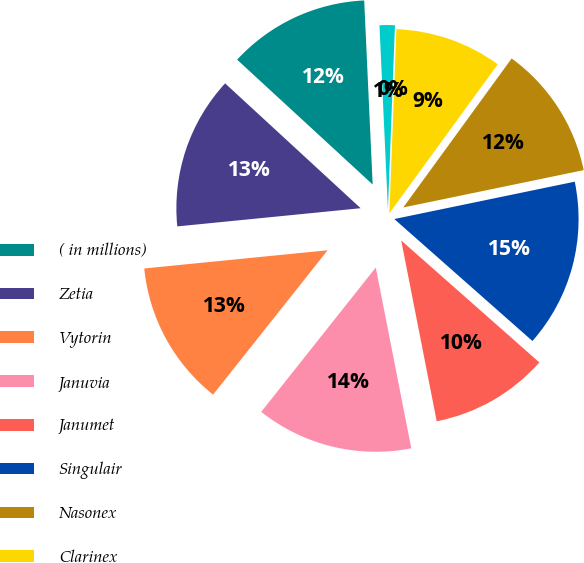Convert chart. <chart><loc_0><loc_0><loc_500><loc_500><pie_chart><fcel>( in millions)<fcel>Zetia<fcel>Vytorin<fcel>Januvia<fcel>Janumet<fcel>Singulair<fcel>Nasonex<fcel>Clarinex<fcel>Dulera<fcel>Asmanex<nl><fcel>12.42%<fcel>13.42%<fcel>12.75%<fcel>13.76%<fcel>10.4%<fcel>14.76%<fcel>11.74%<fcel>9.4%<fcel>0.0%<fcel>1.34%<nl></chart> 